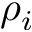Convert formula to latex. <formula><loc_0><loc_0><loc_500><loc_500>\rho _ { i }</formula> 